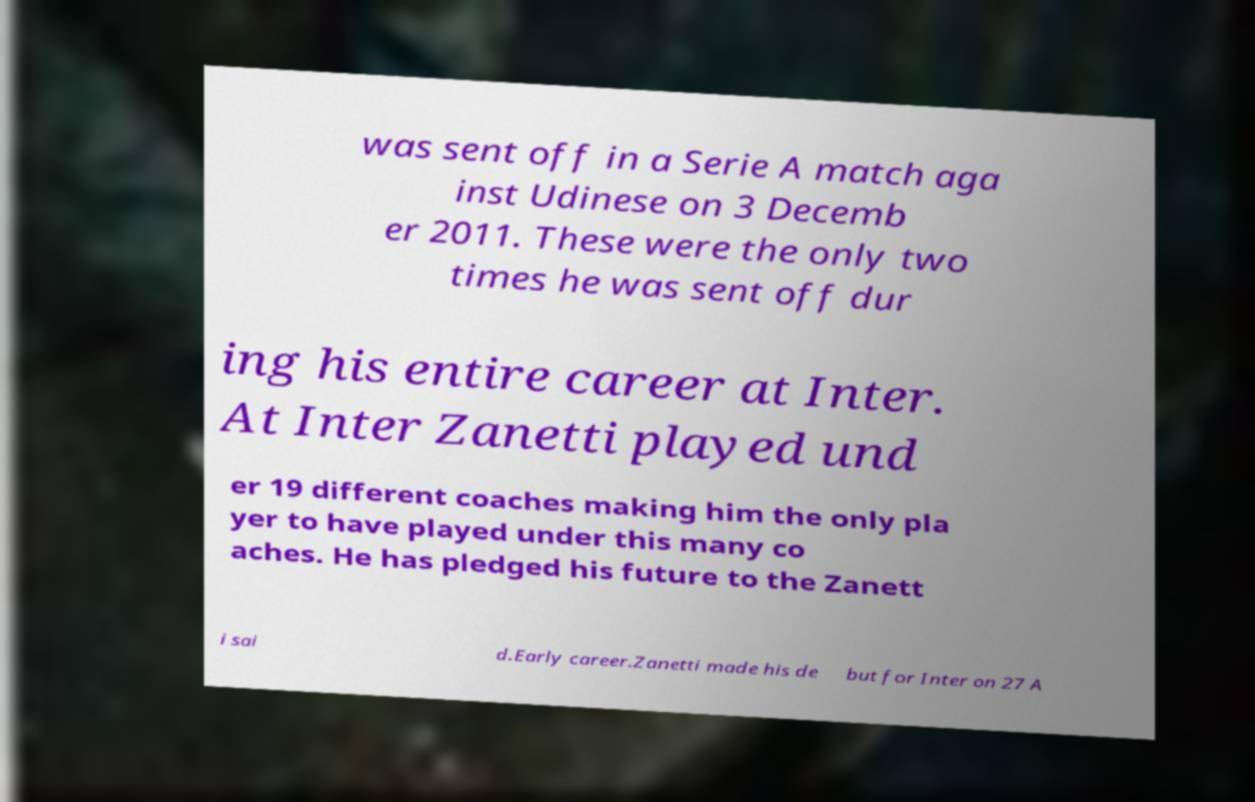Please read and relay the text visible in this image. What does it say? was sent off in a Serie A match aga inst Udinese on 3 Decemb er 2011. These were the only two times he was sent off dur ing his entire career at Inter. At Inter Zanetti played und er 19 different coaches making him the only pla yer to have played under this many co aches. He has pledged his future to the Zanett i sai d.Early career.Zanetti made his de but for Inter on 27 A 